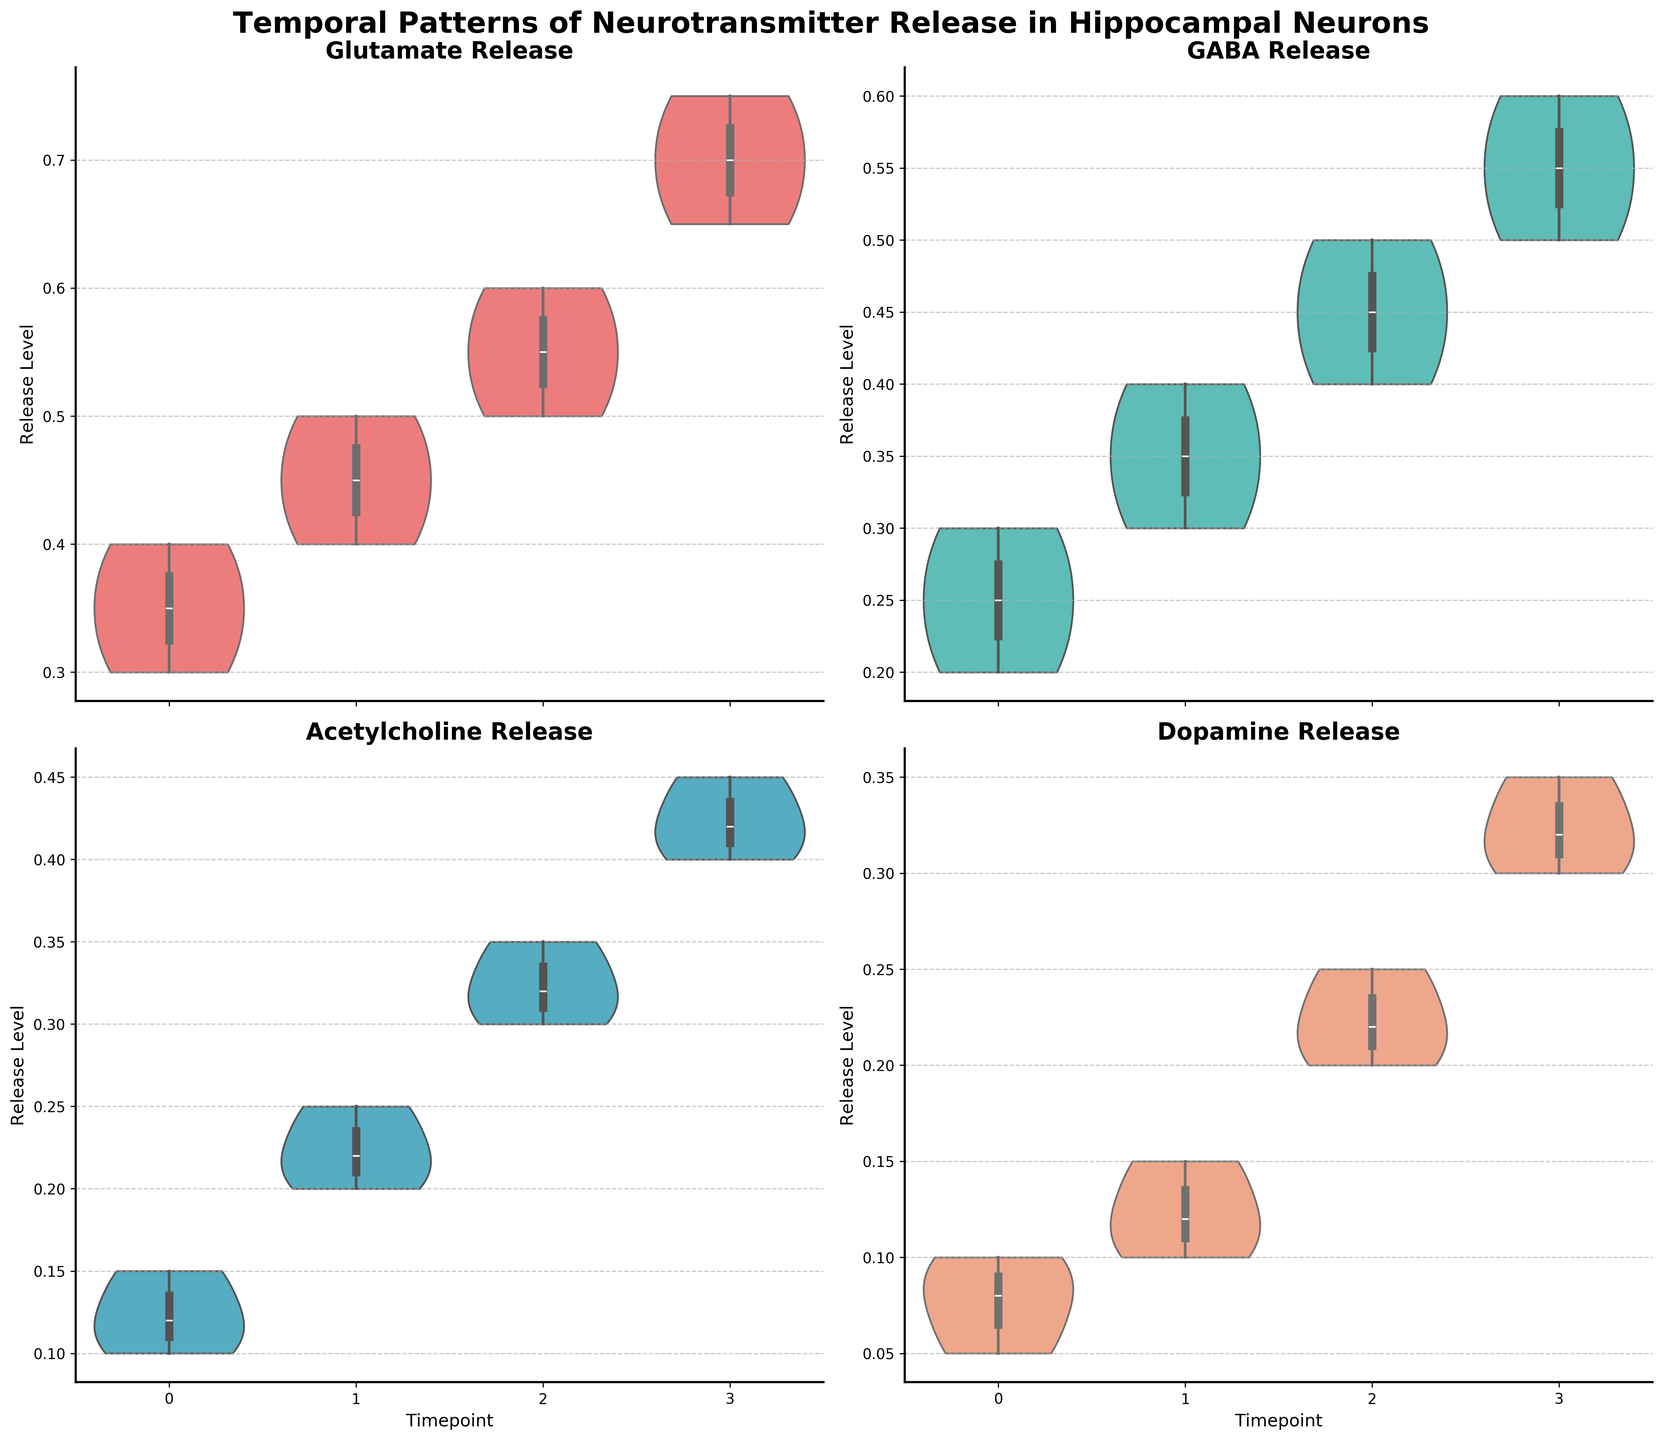What is the title of the figure? The title is usually at the top of the figure and provides a summary of what the figure is about. In this case, it is "Temporal Patterns of Neurotransmitter Release in Hippocampal Neurons."
Answer: Temporal Patterns of Neurotransmitter Release in Hippocampal Neurons Which neurotransmitter has the highest release level at Timepoint 3? Look at the violin plots for Timepoint 3 across all subplots and identify the neurotransmitter with the highest peak. Glutamate has the highest peak at Timepoint 3.
Answer: Glutamate How does the release pattern of GABA change over time? Observe the GABA subplot and track the change in the center and spread of the violin plots across timepoints 0, 1, 2, and 3. The release pattern of GABA shows a gradual increase in both the center and the spread from Timepoint 0 through Timepoint 3.
Answer: Gradually increases Which neurotransmitter shows the least release level at Timepoint 0? Compare the release levels at Timepoint 0 across all four subplots. Dopamine has the lowest release level at Timepoint 0.
Answer: Dopamine At which timepoint does Acetylcholine release peak? Look at the Acetylcholine subplot and identify the timepoint at which the violin plot is the widest or has the highest median value. Acetylcholine peaks at Timepoint 3.
Answer: Timepoint 3 Compare the release levels of Glutamate and GABA at Timepoint 2. Which one is higher? Check the violin plots for Timepoint 2 in both the Glutamate and GABA subplots. Identify which violin plot has a higher central location or peak. Glutamate has a higher release level at Timepoint 2 compared to GABA.
Answer: Glutamate What is the median release level of Dopamine at Timepoint 3? The median value in a violin plot can often be identified by the narrowest section in the middle of the plot or the box plot's central line. For Dopamine at Timepoint 3, the median release level is around 0.32.
Answer: 0.32 How does the spread of release levels of Acetylcholine differ between Timepoint 1 and Timepoint 2? In the violin plots, the spread is indicated by the width of the distribution. Compare the widths at Timepoint 1 and Timepoint 2 for Acetylcholine. The spread is wider at Timepoint 2 compared to Timepoint 1.
Answer: Wider at Timepoint 2 Which neurotransmitter has the most consistent release levels across all timepoints? Consistency can be inferred from violin plots with almost similar widths and centers at each timepoint. Compare all neurotransmitters' subplots. Acetylcholine appears to have the most consistent release levels across all timepoints.
Answer: Acetylcholine 